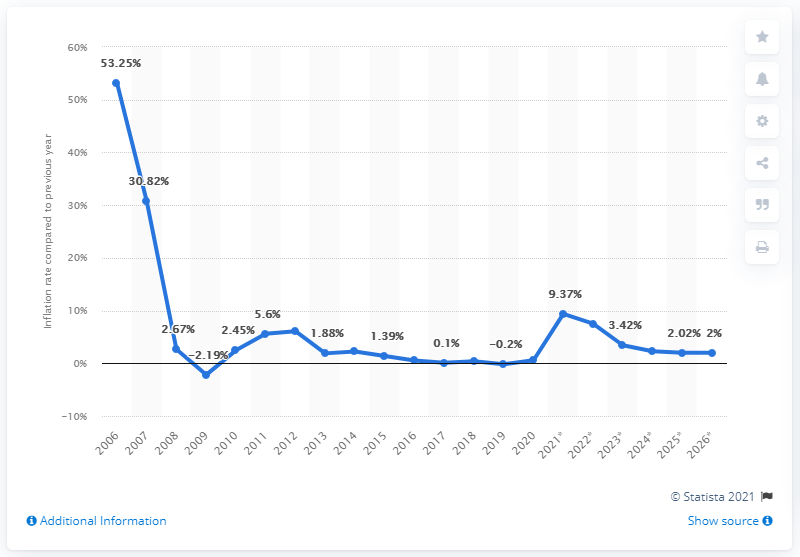Indicate a few pertinent items in this graphic. In 2020, the inflation rate in Iraq was 0.57%. 